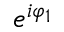Convert formula to latex. <formula><loc_0><loc_0><loc_500><loc_500>e ^ { i \varphi _ { 1 } }</formula> 